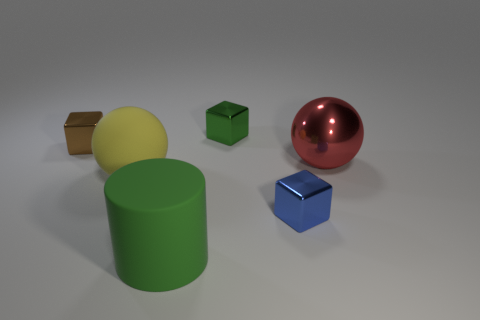How many other things are there of the same size as the blue shiny thing?
Provide a short and direct response. 2. There is a yellow matte thing that is the same shape as the big red thing; what size is it?
Give a very brief answer. Large. There is a thing to the right of the blue metallic thing; what shape is it?
Ensure brevity in your answer.  Sphere. The matte object that is in front of the tiny block in front of the red metal sphere is what color?
Keep it short and to the point. Green. What number of things are tiny metal cubes that are in front of the green block or tiny green objects?
Your answer should be very brief. 3. Is the size of the yellow ball the same as the green thing that is behind the cylinder?
Provide a succinct answer. No. How many big things are either purple objects or green metallic cubes?
Your answer should be very brief. 0. There is a blue thing; what shape is it?
Make the answer very short. Cube. The metallic block that is the same color as the big cylinder is what size?
Give a very brief answer. Small. Are there any large green cylinders that have the same material as the blue cube?
Make the answer very short. No. 